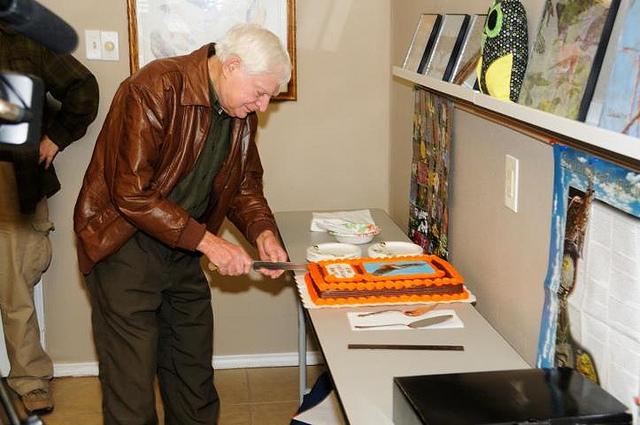Is that Bob Barker?
Keep it brief. No. Is the cake on a kitchen counter?
Give a very brief answer. No. What's the man doing?
Answer briefly. Cutting cake. 